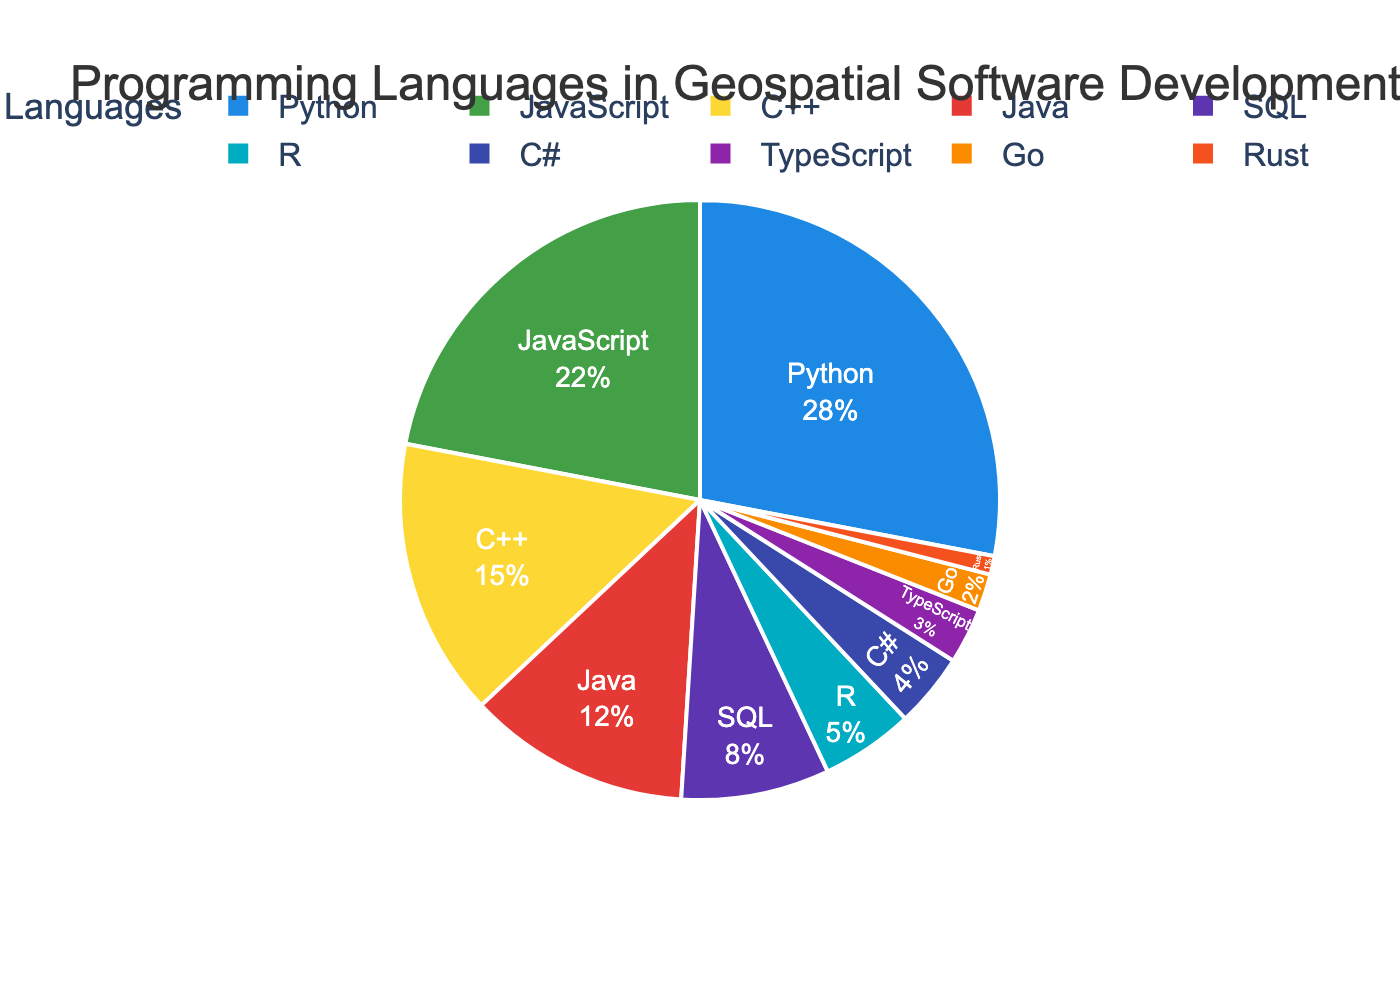What's the most popular programming language for geospatial software development? The largest segment in the pie chart, labeled and colored prominently, represents the programming language with the highest percentage.
Answer: Python How much more percentage does Python have compared to JavaScript? Python is at 28% and JavaScript at 22%. The difference in percentage is calculated by subtracting JavaScript's percentage from Python's. 28 - 22 = 6%.
Answer: 6% Which two languages combined cover the largest portion, and what is that percentage? By scanning for the two largest segments, we find Python (28%) and JavaScript (22%). Adding these two together gives us the combined percentage. 28 + 22 = 50%.
Answer: Python and JavaScript, 50% Are there more languages in the pie chart with a percentage higher or lower than 10%? Count the segments with more than 10% (Python, JavaScript, C++, Java) and those with 10% or less (SQL, R, C#, TypeScript, Go, Rust). There are 4 languages over 10% and 6 under or equal to 10%.
Answer: More languages have a percentage lower than 10% What percentage is dedicated to languages other than the top three (Python, JavaScript, C++)? Sum the percentages of the top three languages: 28% (Python) + 22% (JavaScript) + 15% (C++) = 65%. Subtract this from 100% to find the percentage of the other languages. 100 - 65 = 35%.
Answer: 35% What language has the smallest segment in the pie chart, and what is its percentage? The smallest segment is labeled and colored distinctly, often being the last in the legend. This is Rust at 1%.
Answer: Rust, 1% If you combine the percentages for the least represented languages (Go and Rust), what value do you get? Go is at 2% and Rust at 1%. Adding these together results in 2 + 1 = 3%.
Answer: 3% Which language has a segment with a prominent green color, and what is its percentage? The segment colored prominently green in the custom MapBox-inspired palette is associated with JavaScript.
Answer: JavaScript, 22% What's the total percentage for languages represented in shades of blue in the pie chart? Identify the blue segments: Python (28%) and TypeScript (3%). Sum these to get the total percentage: 28 + 3 = 31%.
Answer: 31% Compare the percentage of C++ with the average percentage of SQL, R, and C#. Which is larger and by how much? First, find the average of SQL, R, and C#: (8 + 5 + 4) / 3 = 17 / 3 ≈ 5.67%. C++ has 15%, so the difference is 15 - 5.67 = 9.33%.
Answer: C++ is larger by 9.33% 